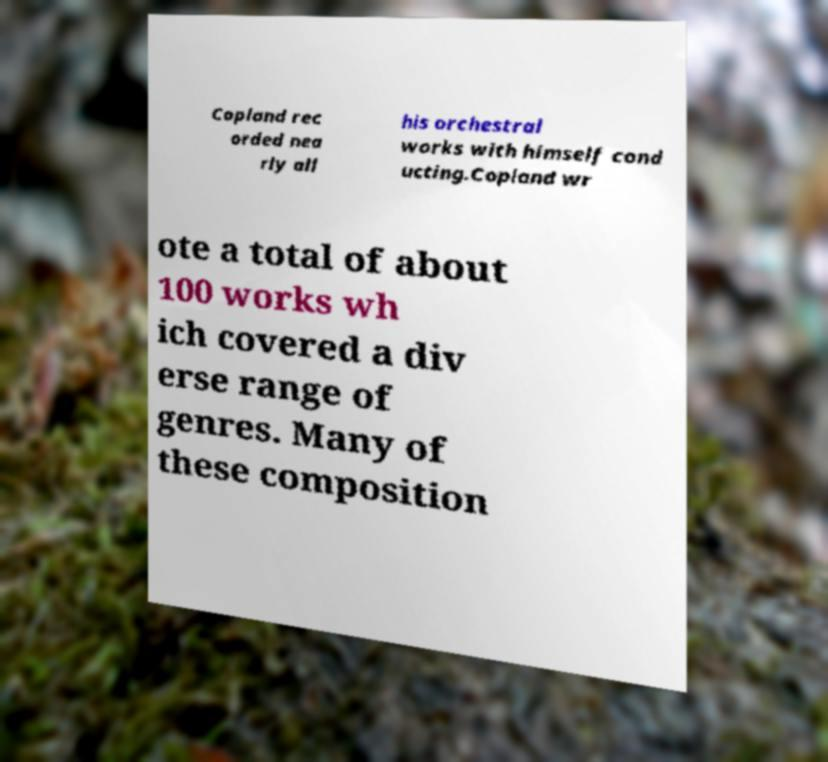Please identify and transcribe the text found in this image. Copland rec orded nea rly all his orchestral works with himself cond ucting.Copland wr ote a total of about 100 works wh ich covered a div erse range of genres. Many of these composition 